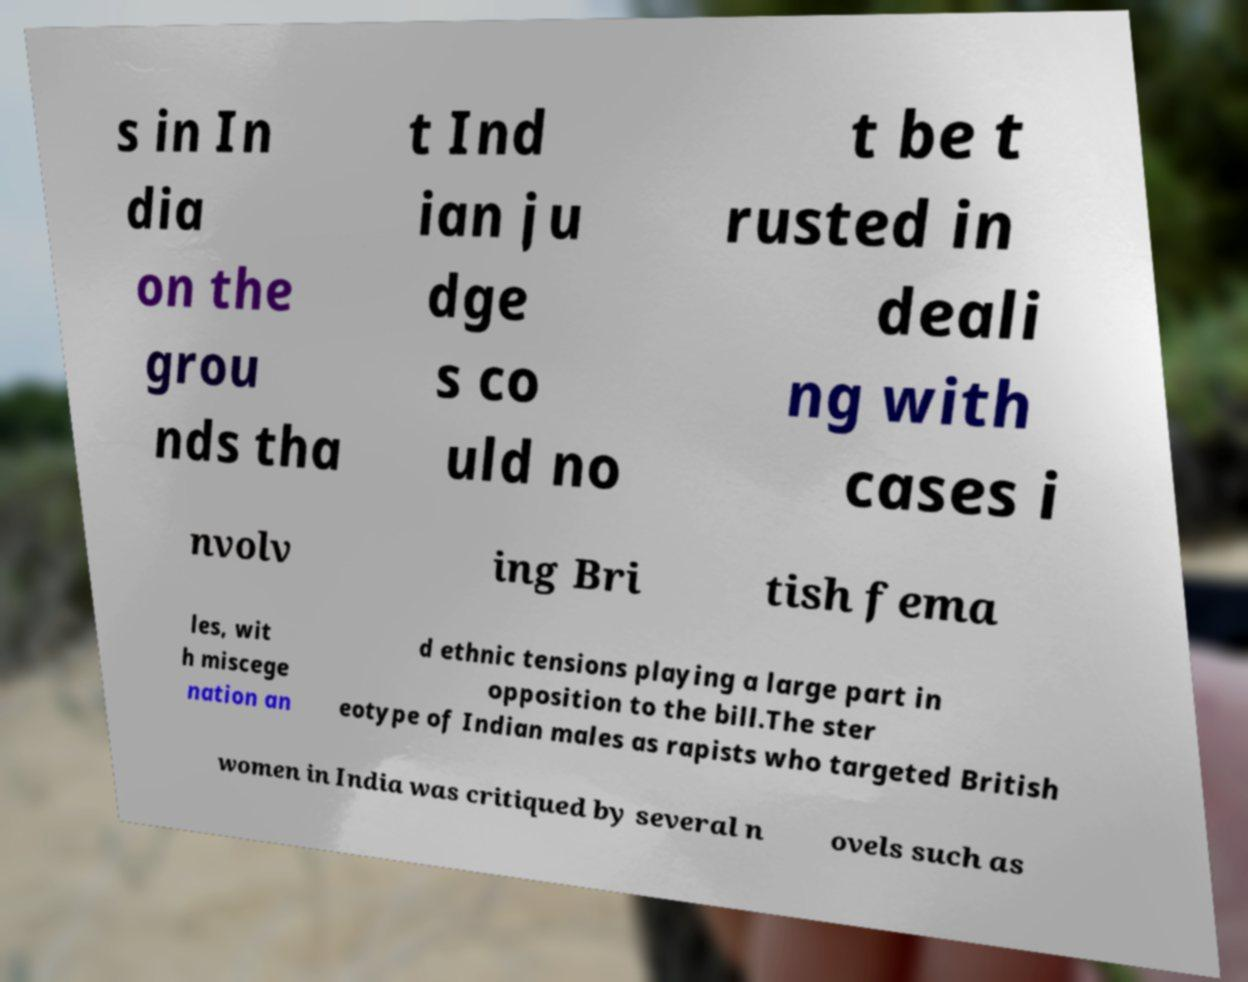Can you accurately transcribe the text from the provided image for me? s in In dia on the grou nds tha t Ind ian ju dge s co uld no t be t rusted in deali ng with cases i nvolv ing Bri tish fema les, wit h miscege nation an d ethnic tensions playing a large part in opposition to the bill.The ster eotype of Indian males as rapists who targeted British women in India was critiqued by several n ovels such as 